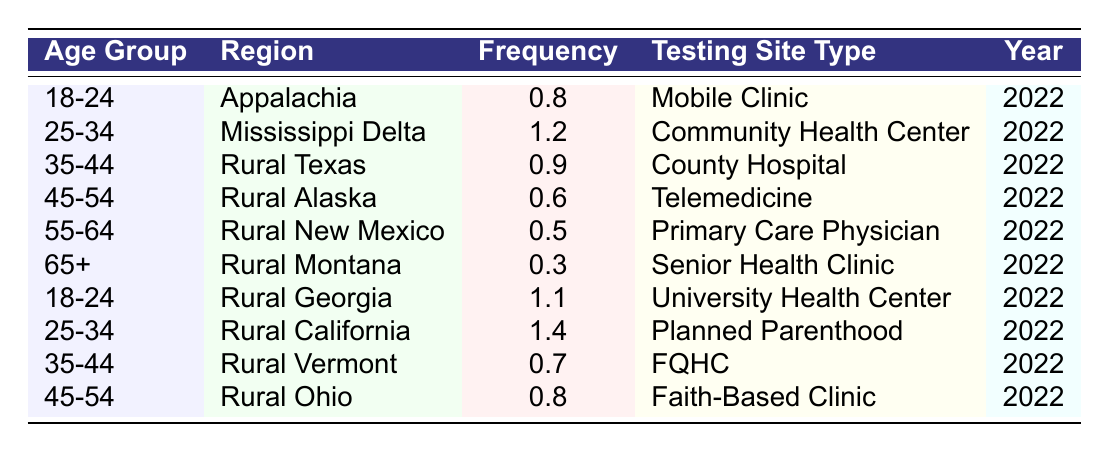What is the testing site type with the highest frequency for the age group 25-34 in the table? For the age group 25-34, we look at the data entries. The entry for Rural California shows a frequency of 1.4 with a "Planned Parenthood" testing site type, which is higher than the frequency of 1.2 at the Mississippi Delta (Community Health Center).
Answer: Planned Parenthood What is the frequency of HIV testing for the age group 45-54 in Rural Ohio? The table has a specific entry for the age group 45-54 in Rural Ohio, which shows a frequency of 0.8. This is a direct retrieval from the table.
Answer: 0.8 Are there any regions where the frequency of testing services exceeds 1 for the age group 18-24? Checking the entries for the age group 18-24, we find two relevant data points: 0.8 in Appalachia and 1.1 in Rural Georgia. The frequency in Rural Georgia exceeds 1, confirming the statement to be true.
Answer: Yes What is the average frequency of HIV testing services across all age groups in the table? First, we find the frequencies: 0.8, 1.2, 0.9, 0.6, 0.5, 0.3, 1.1, 1.4, 0.7, and 0.8. We sum them up: 0.8 + 1.2 + 0.9 + 0.6 + 0.5 + 0.3 + 1.1 + 1.4 + 0.7 + 0.8 = 9.3. There are 10 data points, so we divide the total frequency by 10, giving us an average of 0.93.
Answer: 0.93 What is the difference in frequency of HIV testing services between the age groups 35-44 and 55-64? Looking at the frequencies, 35-44 has a frequency of 0.9, and 55-64 has a frequency of 0.5. The difference is calculated by subtracting: 0.9 - 0.5 = 0.4.
Answer: 0.4 Which age group has the lowest frequency of HIV testing services in the table? By reviewing the data, we find that the age group 65+ in Rural Montana has the lowest frequency at 0.3. All other age groups have higher frequencies.
Answer: 65+ 